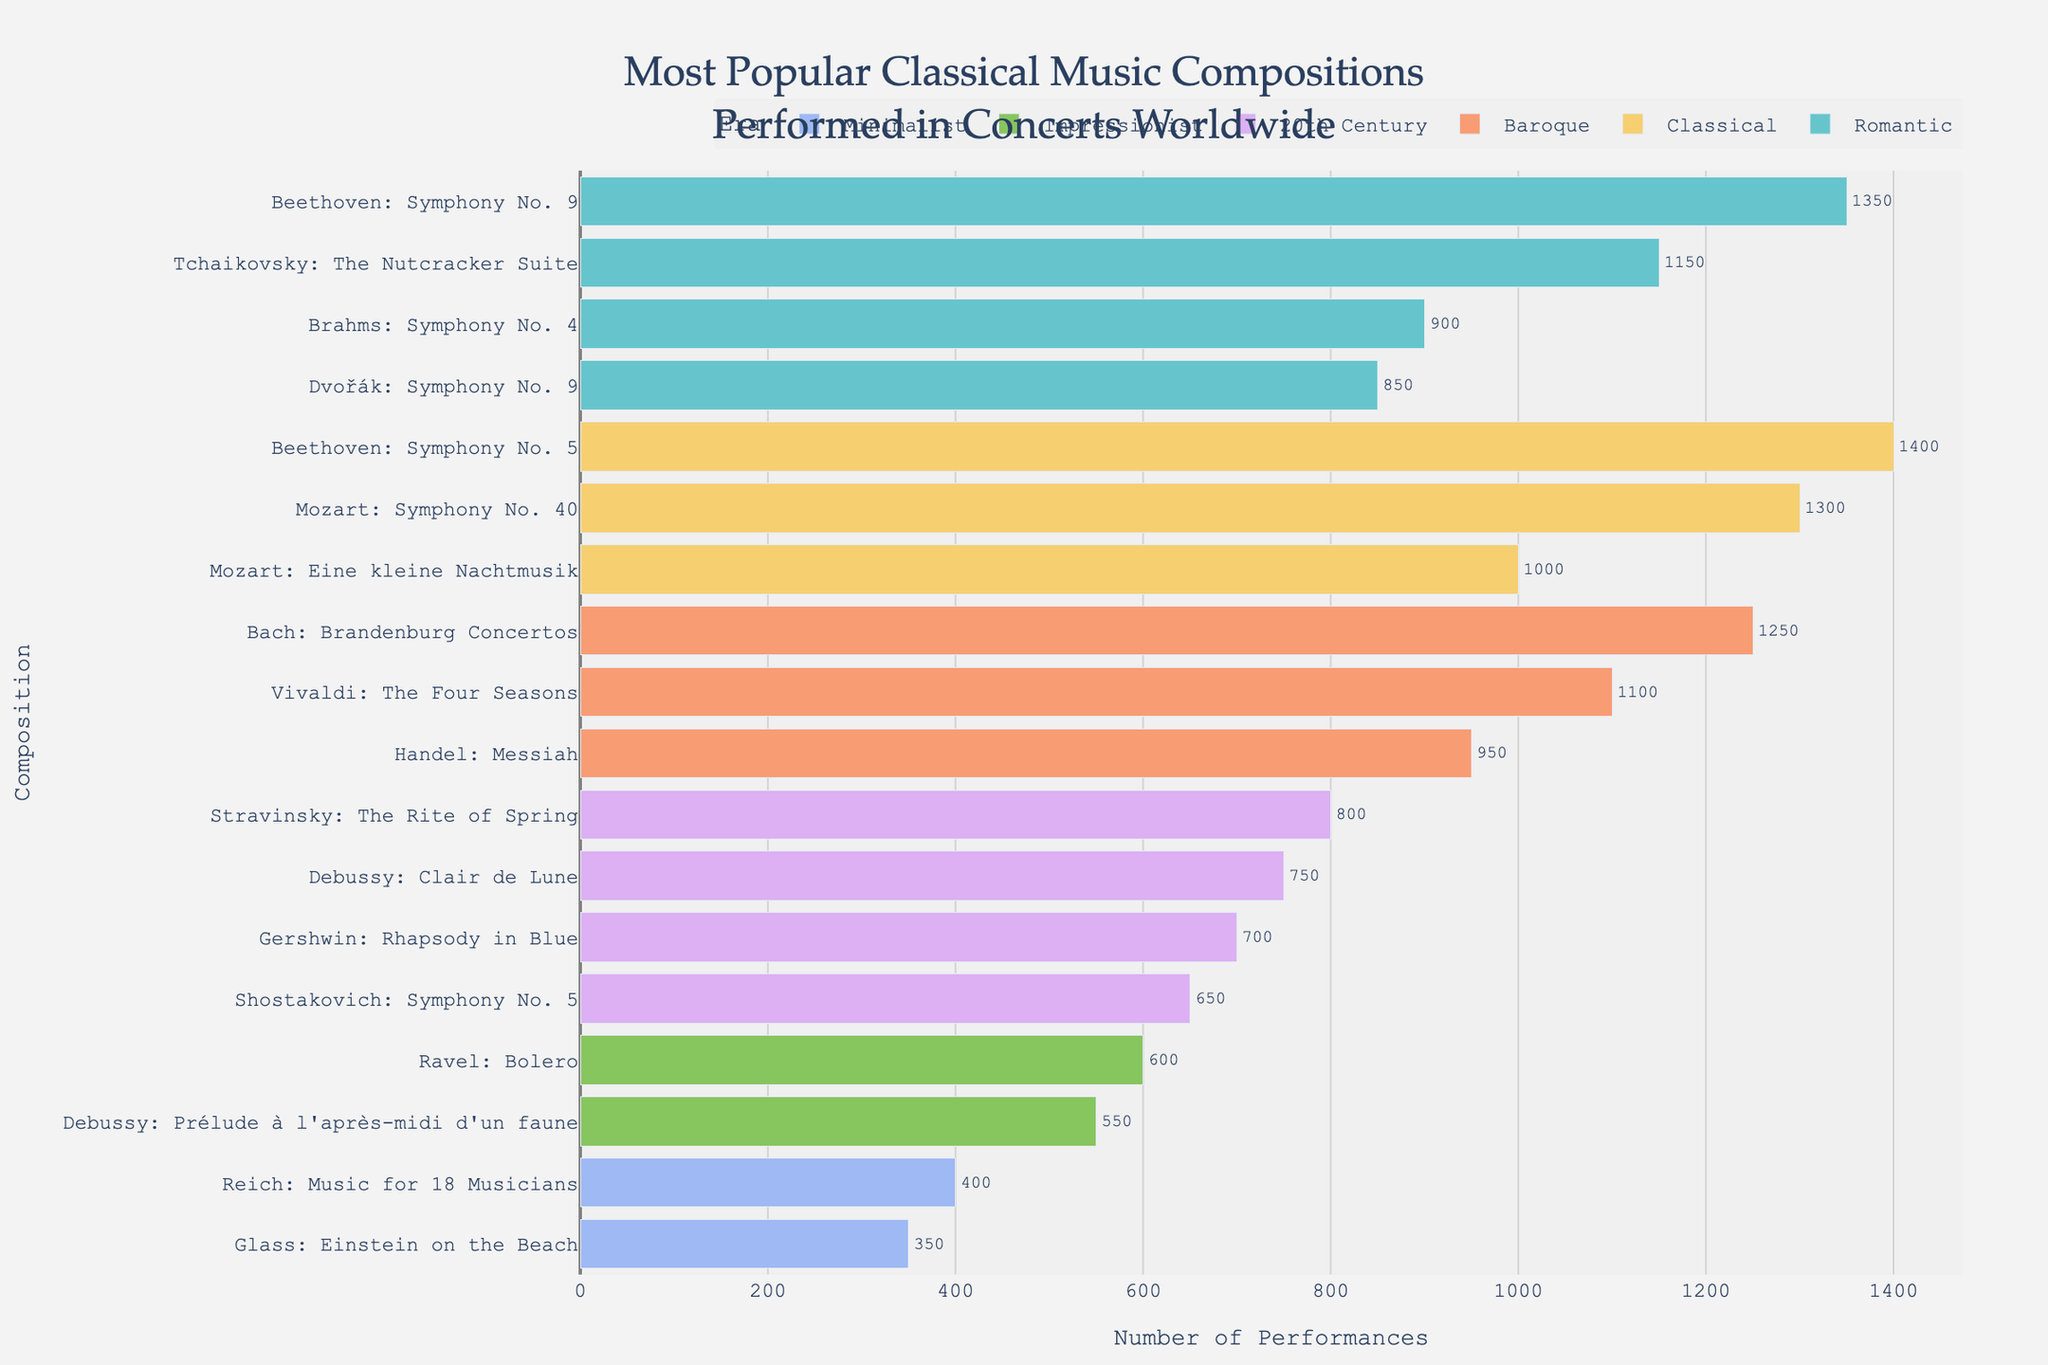Which era has the most total performances? The era with the most total performances can be found by summing the performances of all compositions within each era and comparing the sums. The "Classical" era, with compositions like Beethoven's Symphony No. 5 and Mozart's Symphony No. 40, has the highest total performances.
Answer: Classical How many more performances does Beethoven’s Symphony No. 5 have compared to Glass’s Einstein on the Beach? To find this, subtract the number of performances of Glass’s composition from the number of performances of Beethoven’s composition. Beethoven's Symphony No. 5 has 1,400 performances, while Glass’s Einstein on the Beach has 350. The difference is 1,400 - 350 = 1,050.
Answer: 1,050 Which composition has the second-highest number of performances in the Romantic era? The Romantic era compositions need to be sorted by the number of performances. Upon sorting by performances: Beethoven’s Symphony No. 9 (1,350) and Tchaikovsky's The Nutcracker Suite (1,150) are the top two. Tchaikovsky’s The Nutcracker Suite is second.
Answer: Tchaikovsky: The Nutcracker Suite Are there any compositions from the Impressionist era that have more performances than Shostakovich's Symphony No. 5 from the 20th Century? Shostakovich’s Symphony No. 5 has 650 performances. Both compositions from the Impressionist era, Ravel's Bolero (600) and Debussy's Prélude à l'après-midi d'un faune (550), have fewer performances. Hence, the answer is no.
Answer: No What is the combined number of performances for all Minimalist era compositions? The Minimalist era compositions listed are Reich's Music for 18 Musicians (400) and Glass’s Einstein on the Beach (350). The total is the sum of these performances: 400 + 350 = 750.
Answer: 750 